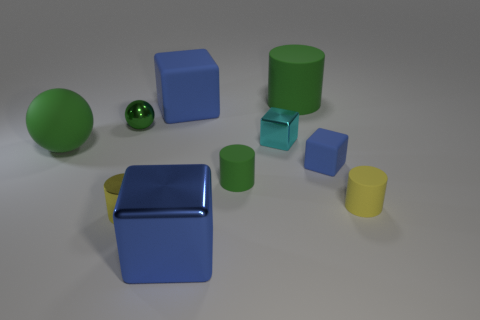Is the number of tiny green metallic spheres in front of the small yellow shiny cylinder less than the number of matte cylinders?
Offer a very short reply. Yes. How many big blue metal objects are in front of the blue rubber object that is in front of the tiny shiny cube?
Provide a short and direct response. 1. How many other objects are there of the same size as the blue metallic thing?
Provide a succinct answer. 3. What number of things are either big green objects or blue objects that are behind the large metal block?
Provide a succinct answer. 4. Are there fewer large red cylinders than matte spheres?
Give a very brief answer. Yes. What color is the tiny matte cylinder that is on the right side of the blue object to the right of the tiny cyan metal cube?
Your answer should be very brief. Yellow. There is a large green thing that is the same shape as the small yellow matte object; what material is it?
Offer a very short reply. Rubber. How many shiny things are either blue things or cylinders?
Provide a succinct answer. 2. Is the small sphere behind the yellow rubber thing made of the same material as the blue thing that is behind the small shiny sphere?
Your response must be concise. No. Is there a large green object?
Provide a succinct answer. Yes. 